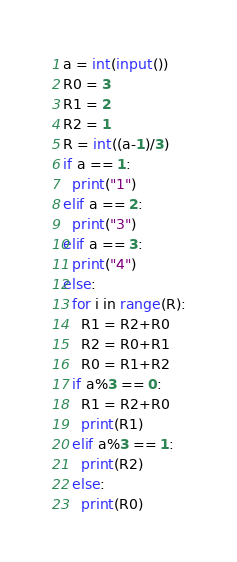Convert code to text. <code><loc_0><loc_0><loc_500><loc_500><_Python_>a = int(input())
R0 = 3
R1 = 2
R2 = 1
R = int((a-1)/3)
if a == 1:
  print("1")
elif a == 2:
  print("3")
elif a == 3:
  print("4")
else:
  for i in range(R):
    R1 = R2+R0
    R2 = R0+R1
    R0 = R1+R2
  if a%3 == 0:
    R1 = R2+R0
    print(R1)
  elif a%3 == 1:
    print(R2)
  else:
    print(R0)</code> 